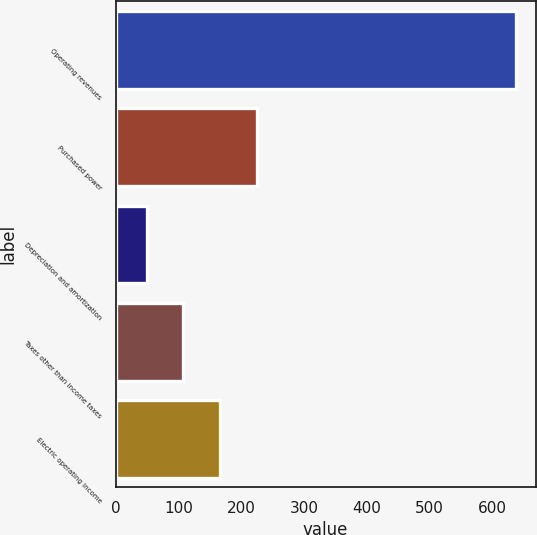Convert chart. <chart><loc_0><loc_0><loc_500><loc_500><bar_chart><fcel>Operating revenues<fcel>Purchased power<fcel>Depreciation and amortization<fcel>Taxes other than income taxes<fcel>Electric operating income<nl><fcel>637<fcel>225.4<fcel>49<fcel>107.8<fcel>166.6<nl></chart> 